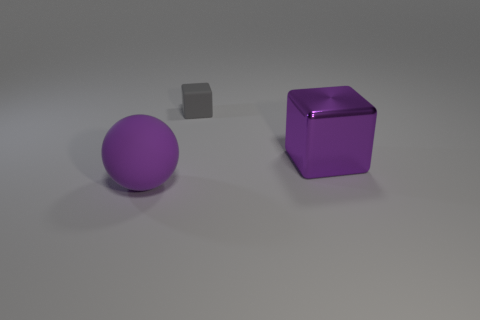There is a ball that is the same color as the large block; what material is it?
Make the answer very short. Rubber. There is a matte sphere; is it the same color as the block that is in front of the small gray rubber cube?
Your response must be concise. Yes. How many other objects are the same color as the big matte thing?
Make the answer very short. 1. Is there anything else that has the same shape as the purple matte object?
Give a very brief answer. No. How big is the purple object behind the object left of the gray cube?
Ensure brevity in your answer.  Large. What number of things are gray cylinders or gray cubes?
Keep it short and to the point. 1. Is there a metallic thing that has the same color as the large matte object?
Keep it short and to the point. Yes. Are there fewer small cyan matte cylinders than purple blocks?
Give a very brief answer. Yes. How many objects are purple metal spheres or big purple objects to the right of the purple rubber thing?
Your response must be concise. 1. Is there a gray object that has the same material as the sphere?
Give a very brief answer. Yes. 